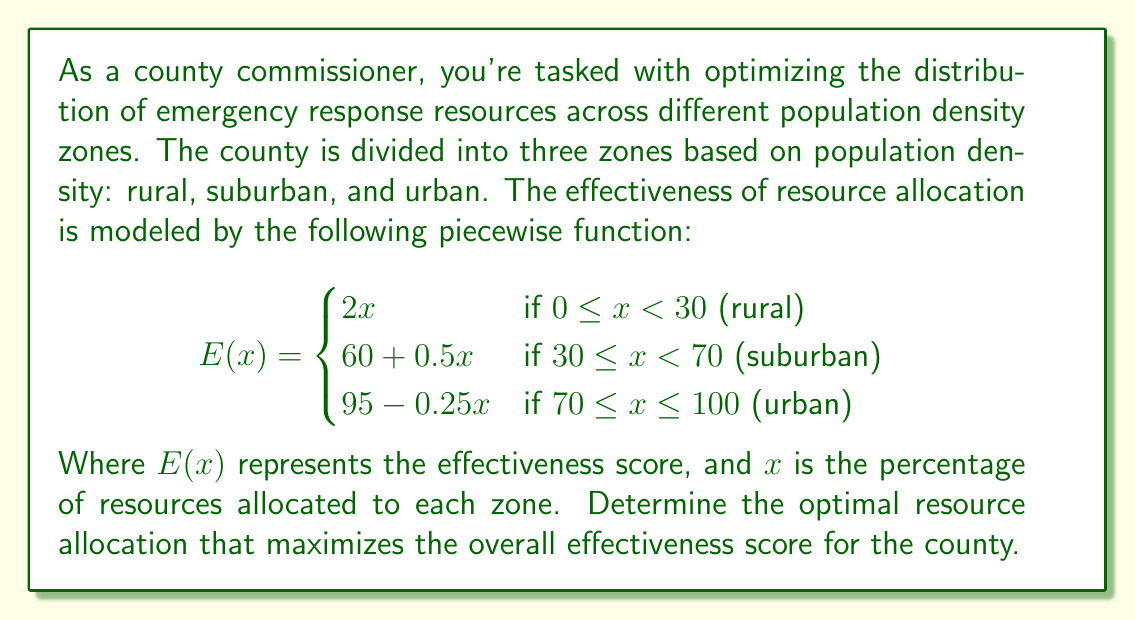Help me with this question. To solve this problem, we need to follow these steps:

1) First, we need to find the maximum value of $E(x)$ for each piece of the function.

2) For the rural zone $(0 \leq x < 30)$:
   $E(x) = 2x$
   This is a linear function that increases as $x$ increases. The maximum value will occur at the upper bound, $x = 30$.
   $E(30) = 2(30) = 60$

3) For the suburban zone $(30 \leq x < 70)$:
   $E(x) = 60 + 0.5x$
   This is also a linear function that increases as $x$ increases. The maximum value will occur at the upper bound, $x = 70$.
   $E(70) = 60 + 0.5(70) = 95$

4) For the urban zone $(70 \leq x \leq 100)$:
   $E(x) = 95 - 0.25x$
   This is a linear function that decreases as $x$ increases. The maximum value will occur at the lower bound, $x = 70$.
   $E(70) = 95 - 0.25(70) = 77.5$

5) Comparing these maximum values:
   Rural: 60
   Suburban: 95
   Urban: 77.5

6) The overall maximum occurs in the suburban zone when $x = 70$.

7) This means that the optimal allocation is:
   70% to suburban areas
   30% to rural areas (since the rural function is increasing up to x = 30)
   0% to urban areas

Therefore, the optimal resource allocation that maximizes the overall effectiveness score is 70% to suburban areas and 30% to rural areas.
Answer: The optimal resource allocation is 70% to suburban areas and 30% to rural areas, resulting in a maximum effectiveness score of 95. 